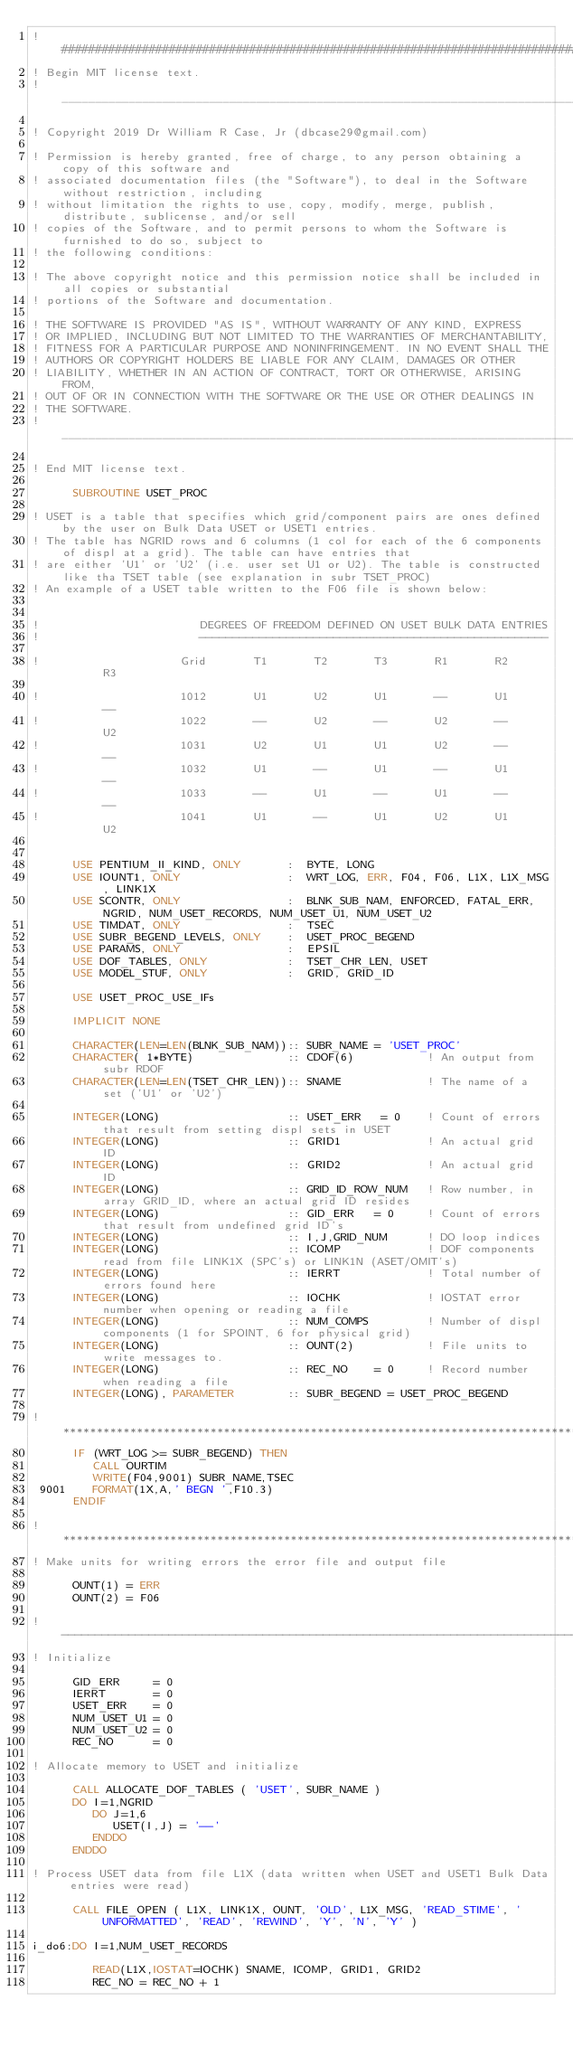<code> <loc_0><loc_0><loc_500><loc_500><_FORTRAN_>! ##################################################################################################################################
! Begin MIT license text.                                                                                    
! _______________________________________________________________________________________________________
                                                                                                         
! Copyright 2019 Dr William R Case, Jr (dbcase29@gmail.com)                                              
                                                                                                         
! Permission is hereby granted, free of charge, to any person obtaining a copy of this software and      
! associated documentation files (the "Software"), to deal in the Software without restriction, including
! without limitation the rights to use, copy, modify, merge, publish, distribute, sublicense, and/or sell
! copies of the Software, and to permit persons to whom the Software is furnished to do so, subject to   
! the following conditions:                                                                              
                                                                                                         
! The above copyright notice and this permission notice shall be included in all copies or substantial   
! portions of the Software and documentation.                                                                              
                                                                                                         
! THE SOFTWARE IS PROVIDED "AS IS", WITHOUT WARRANTY OF ANY KIND, EXPRESS                                
! OR IMPLIED, INCLUDING BUT NOT LIMITED TO THE WARRANTIES OF MERCHANTABILITY,                            
! FITNESS FOR A PARTICULAR PURPOSE AND NONINFRINGEMENT. IN NO EVENT SHALL THE                            
! AUTHORS OR COPYRIGHT HOLDERS BE LIABLE FOR ANY CLAIM, DAMAGES OR OTHER                                 
! LIABILITY, WHETHER IN AN ACTION OF CONTRACT, TORT OR OTHERWISE, ARISING FROM,                          
! OUT OF OR IN CONNECTION WITH THE SOFTWARE OR THE USE OR OTHER DEALINGS IN                              
! THE SOFTWARE.                                                                                          
! _______________________________________________________________________________________________________
                                                                                                        
! End MIT license text.                                                                                      

      SUBROUTINE USET_PROC
 
! USET is a table that specifies which grid/component pairs are ones defined by the user on Bulk Data USET or USET1 entries.
! The table has NGRID rows and 6 columns (1 col for each of the 6 components of displ at a grid). The table can have entries that
! are either 'U1' or 'U2' (i.e. user set U1 or U2). The table is constructed like tha TSET table (see explanation in subr TSET_PROC)
! An example of a USET table written to the F06 file is shown below:


!                        DEGREES OF FREEDOM DEFINED ON USET BULK DATA ENTRIES
!                        ----------------------------------------------------

!                     Grid       T1       T2       T3       R1       R2       R3

!                     1012       U1       U2       U1       --       U1       --
!                     1022       --       U2       --       U2       --       U2
!                     1031       U2       U1       U1       U2       --       --
!                     1032       U1       --       U1       --       U1       --
!                     1033       --       U1       --       U1       --       --
!                     1041       U1       --       U1       U2       U1       U2

 
      USE PENTIUM_II_KIND, ONLY       :  BYTE, LONG
      USE IOUNT1, ONLY                :  WRT_LOG, ERR, F04, F06, L1X, L1X_MSG, LINK1X
      USE SCONTR, ONLY                :  BLNK_SUB_NAM, ENFORCED, FATAL_ERR, NGRID, NUM_USET_RECORDS, NUM_USET_U1, NUM_USET_U2
      USE TIMDAT, ONLY                :  TSEC
      USE SUBR_BEGEND_LEVELS, ONLY    :  USET_PROC_BEGEND
      USE PARAMS, ONLY                :  EPSIL
      USE DOF_TABLES, ONLY            :  TSET_CHR_LEN, USET
      USE MODEL_STUF, ONLY            :  GRID, GRID_ID
 
      USE USET_PROC_USE_IFs

      IMPLICIT NONE

      CHARACTER(LEN=LEN(BLNK_SUB_NAM)):: SUBR_NAME = 'USET_PROC'
      CHARACTER( 1*BYTE)              :: CDOF(6)           ! An output from subr RDOF
      CHARACTER(LEN=LEN(TSET_CHR_LEN)):: SNAME             ! The name of a set ('U1' or 'U2')
 
      INTEGER(LONG)                   :: USET_ERR   = 0    ! Count of errors that result from setting displ sets in USET
      INTEGER(LONG)                   :: GRID1             ! An actual grid ID
      INTEGER(LONG)                   :: GRID2             ! An actual grid ID
      INTEGER(LONG)                   :: GRID_ID_ROW_NUM   ! Row number, in array GRID_ID, where an actual grid ID resides
      INTEGER(LONG)                   :: GID_ERR   = 0     ! Count of errors that result from undefined grid ID's
      INTEGER(LONG)                   :: I,J,GRID_NUM      ! DO loop indices
      INTEGER(LONG)                   :: ICOMP             ! DOF components read from file LINK1X (SPC's) or LINK1N (ASET/OMIT's)
      INTEGER(LONG)                   :: IERRT             ! Total number of errors found here
      INTEGER(LONG)                   :: IOCHK             ! IOSTAT error number when opening or reading a file
      INTEGER(LONG)                   :: NUM_COMPS         ! Number of displ components (1 for SPOINT, 6 for physical grid)
      INTEGER(LONG)                   :: OUNT(2)           ! File units to write messages to.   
      INTEGER(LONG)                   :: REC_NO    = 0     ! Record number when reading a file
      INTEGER(LONG), PARAMETER        :: SUBR_BEGEND = USET_PROC_BEGEND
 
! **********************************************************************************************************************************
      IF (WRT_LOG >= SUBR_BEGEND) THEN
         CALL OURTIM
         WRITE(F04,9001) SUBR_NAME,TSEC
 9001    FORMAT(1X,A,' BEGN ',F10.3)
      ENDIF

! **********************************************************************************************************************************
! Make units for writing errors the error file and output file
 
      OUNT(1) = ERR
      OUNT(2) = F06
 
! ----------------------------------------------------------------------------------------------------------------------------------
! Initialize

      GID_ERR     = 0
      IERRT       = 0
      USET_ERR    = 0
      NUM_USET_U1 = 0
      NUM_USET_U2 = 0
      REC_NO      = 0

! Allocate memory to USET and initialize

      CALL ALLOCATE_DOF_TABLES ( 'USET', SUBR_NAME )
      DO I=1,NGRID
         DO J=1,6
            USET(I,J) = '--'
         ENDDO
      ENDDO

! Process USET data from file L1X (data written when USET and USET1 Bulk Data entries were read)
 
      CALL FILE_OPEN ( L1X, LINK1X, OUNT, 'OLD', L1X_MSG, 'READ_STIME', 'UNFORMATTED', 'READ', 'REWIND', 'Y', 'N', 'Y' )

i_do6:DO I=1,NUM_USET_RECORDS
 
         READ(L1X,IOSTAT=IOCHK) SNAME, ICOMP, GRID1, GRID2
         REC_NO = REC_NO + 1</code> 